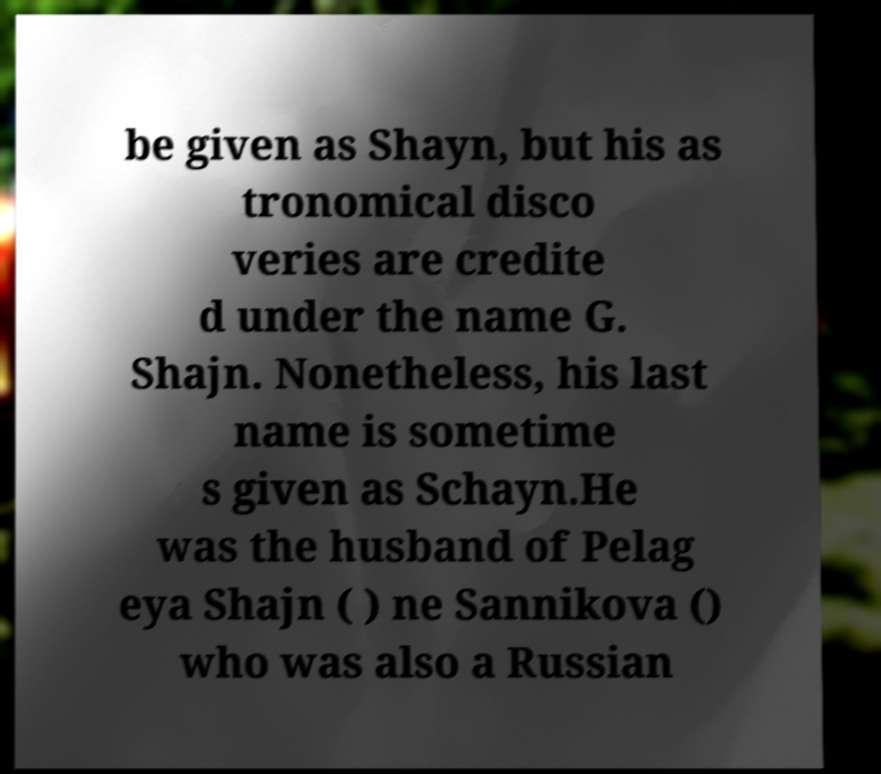Please read and relay the text visible in this image. What does it say? be given as Shayn, but his as tronomical disco veries are credite d under the name G. Shajn. Nonetheless, his last name is sometime s given as Schayn.He was the husband of Pelag eya Shajn ( ) ne Sannikova () who was also a Russian 